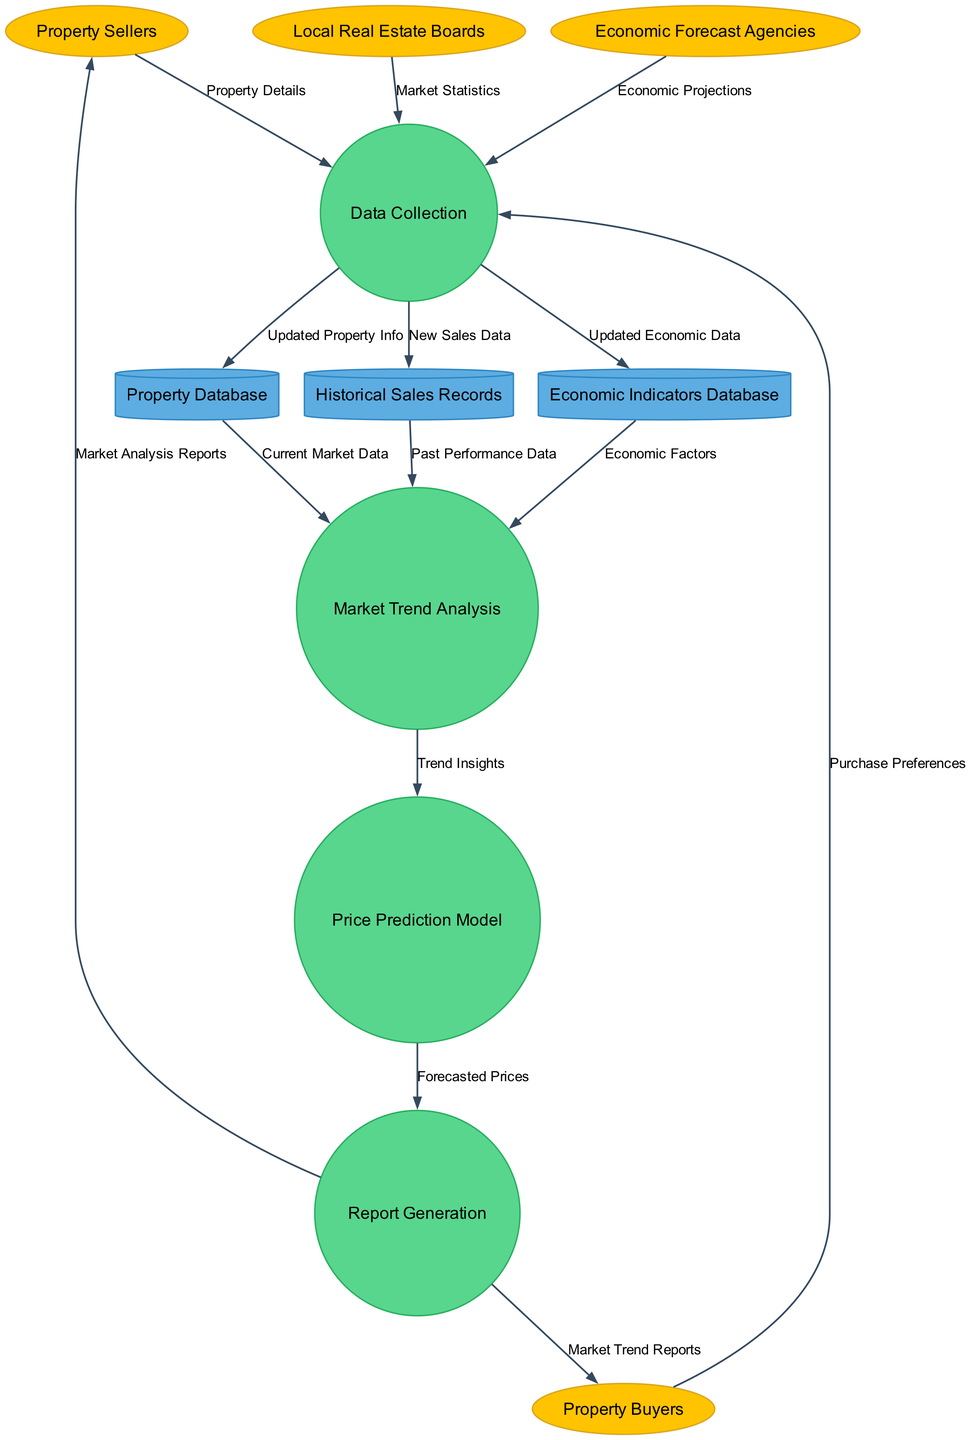What are the external entities in this diagram? The external entities are shown as ellipses in the diagram. They include Property Sellers, Property Buyers, Local Real Estate Boards, and Economic Forecast Agencies, which are directly involved with the processes.
Answer: Property Sellers, Property Buyers, Local Real Estate Boards, Economic Forecast Agencies How many processes are represented in the diagram? The processes are represented as circles and the diagram shows four processes in total: Data Collection, Market Trend Analysis, Price Prediction Model, and Report Generation.
Answer: Four Which data store receives updated economic data? The Economic Indicators Database is depicted as a cylinder in the diagram, receiving updated economic data directly from the Data Collection process.
Answer: Economic Indicators Database What is the label of the flow from Market Trend Analysis to Price Prediction Model? According to the diagram, the label of the flow from Market Trend Analysis to Price Prediction Model is "Trend Insights." This indicates the information used to inform the price prediction.
Answer: Trend Insights What is the role of the Property Database in this system? The Property Database receives current market data from the Data Collection process and provides this data to the Market Trend Analysis process, which uses it to understand current market conditions.
Answer: Current Market Data How many data flows originate from the Data Collection process? By examining the arrows drawn from the Data Collection process in the diagram, we can count three distinct outgoing flows, indicating its connections to the Property Database, Historical Sales Records, and Economic Indicators Database.
Answer: Three What type of reports are generated for Property Buyers? In the diagram, the Report Generation process outputs "Market Trend Reports" specifically for Property Buyers, highlighting its relevance to their interests in property trends.
Answer: Market Trend Reports Which two data sources are sent to Market Trend Analysis? The diagram shows two data stores—Property Database and Historical Sales Records—that provide data to the Market Trend Analysis process, contributing essential historical and current performance metrics.
Answer: Property Database, Historical Sales Records Which external entity provides market statistics? The diagram indicates that Local Real Estate Boards provide market statistics, which flow into the Data Collection process as a source of information.
Answer: Local Real Estate Boards 